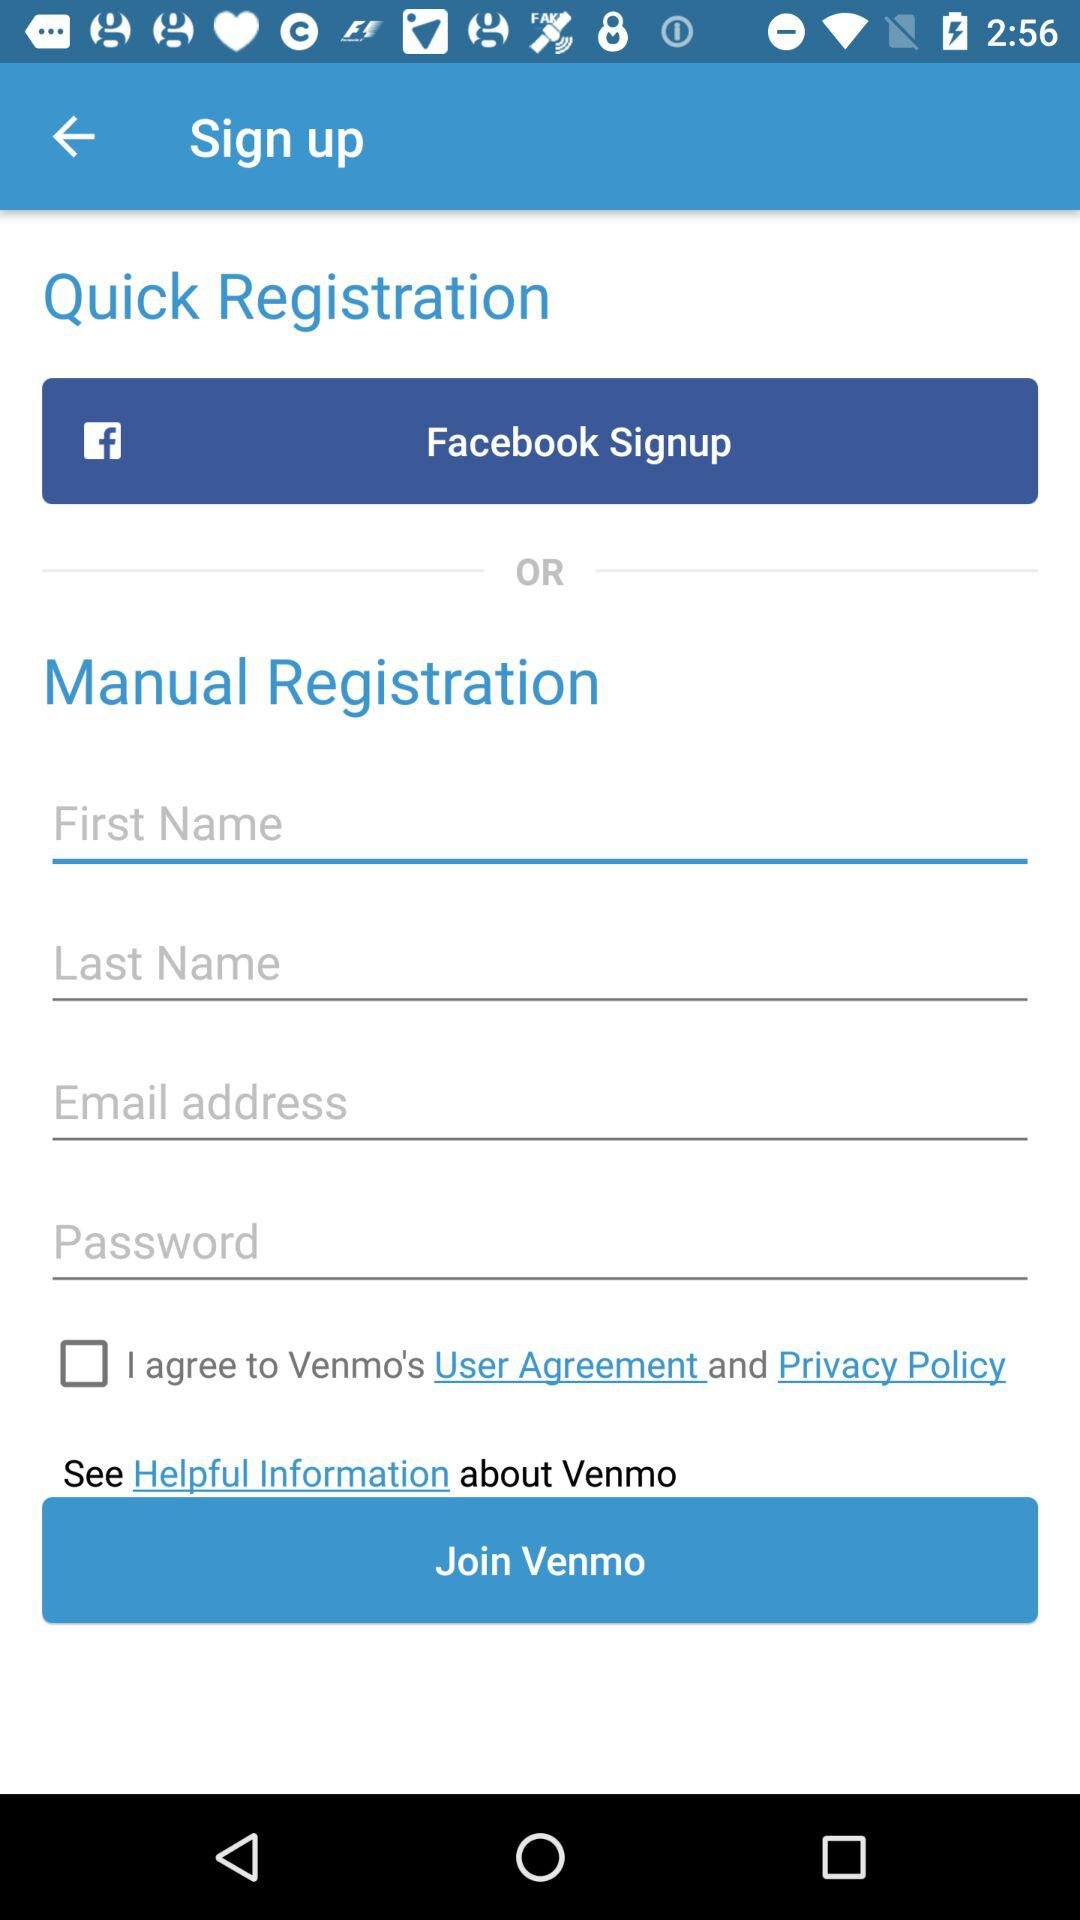What are the sign-up options? The sign-up options are "Facebook" and "Email address". 